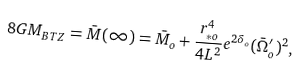Convert formula to latex. <formula><loc_0><loc_0><loc_500><loc_500>8 G M _ { B T Z } = \bar { M } ( \infty ) = \bar { M } _ { o } + \frac { r _ { * o } ^ { 4 } } { 4 L ^ { 2 } } e ^ { 2 \delta _ { o } } ( \bar { \Omega } _ { o } ^ { \prime } ) ^ { 2 } ,</formula> 